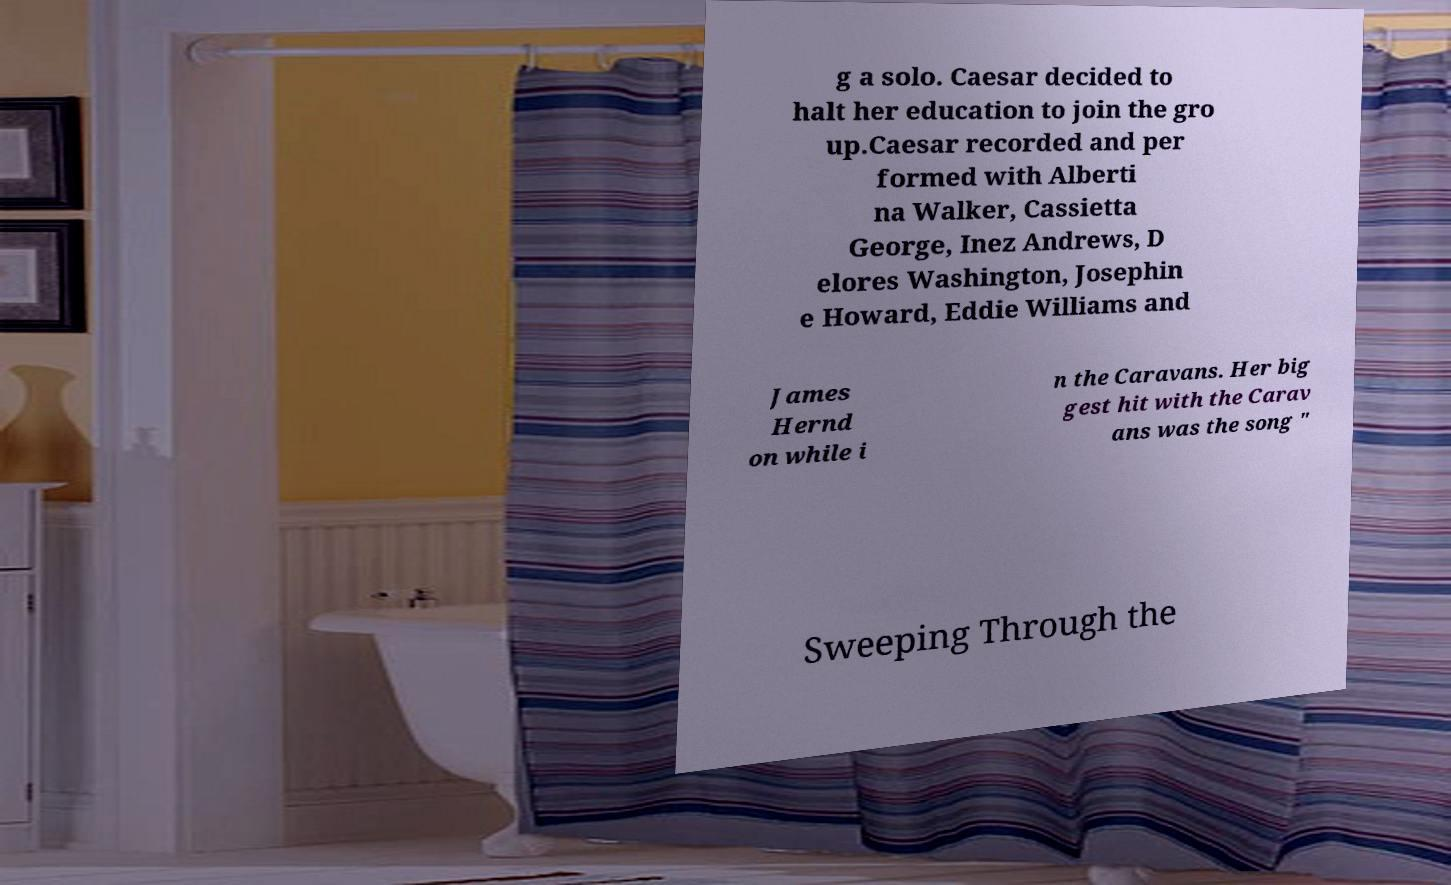There's text embedded in this image that I need extracted. Can you transcribe it verbatim? g a solo. Caesar decided to halt her education to join the gro up.Caesar recorded and per formed with Alberti na Walker, Cassietta George, Inez Andrews, D elores Washington, Josephin e Howard, Eddie Williams and James Hernd on while i n the Caravans. Her big gest hit with the Carav ans was the song " Sweeping Through the 